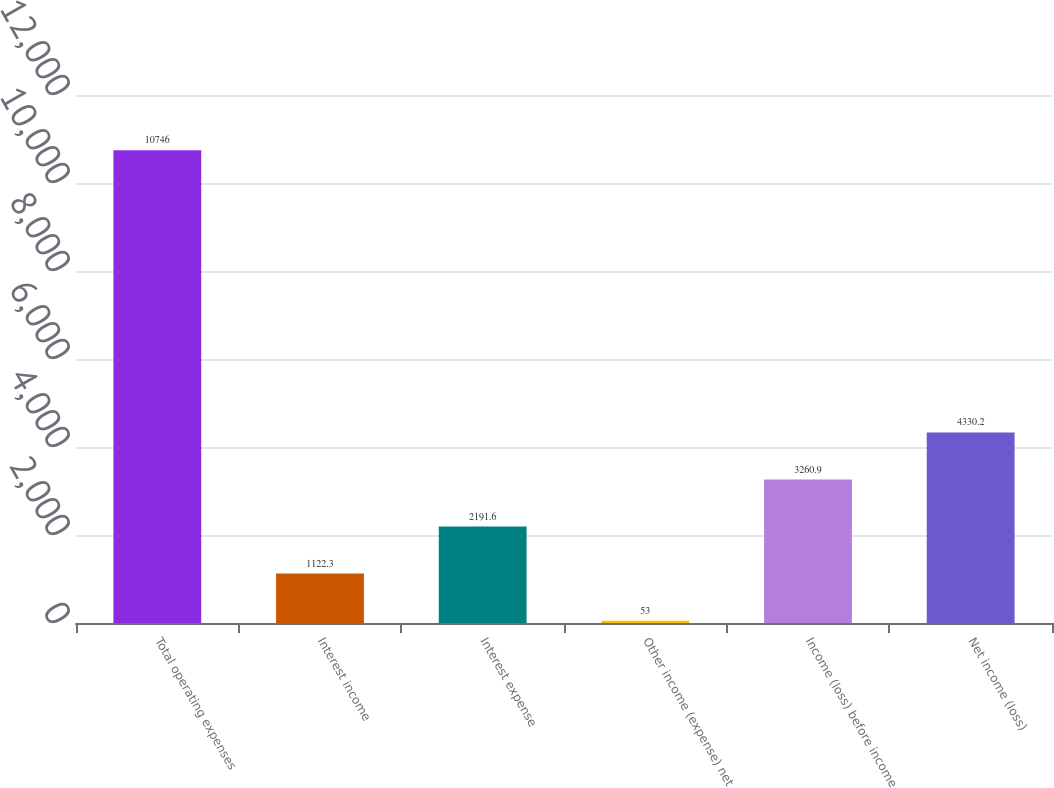Convert chart to OTSL. <chart><loc_0><loc_0><loc_500><loc_500><bar_chart><fcel>Total operating expenses<fcel>Interest income<fcel>Interest expense<fcel>Other income (expense) net<fcel>Income (loss) before income<fcel>Net income (loss)<nl><fcel>10746<fcel>1122.3<fcel>2191.6<fcel>53<fcel>3260.9<fcel>4330.2<nl></chart> 